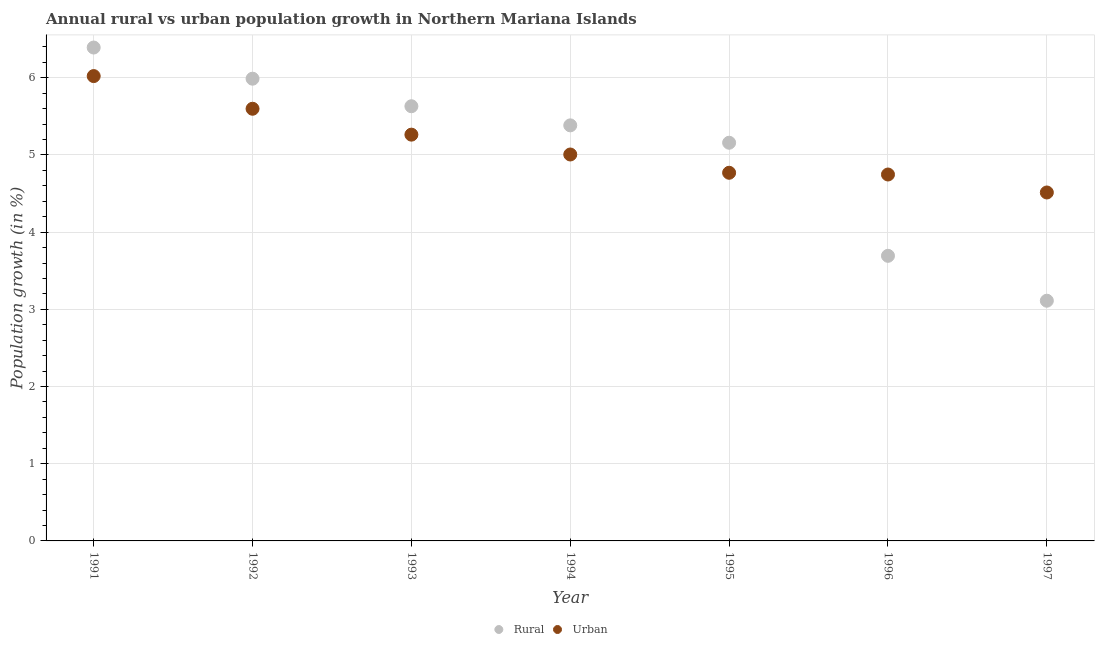How many different coloured dotlines are there?
Make the answer very short. 2. What is the urban population growth in 1996?
Your answer should be compact. 4.75. Across all years, what is the maximum rural population growth?
Keep it short and to the point. 6.39. Across all years, what is the minimum urban population growth?
Give a very brief answer. 4.51. In which year was the rural population growth maximum?
Your answer should be very brief. 1991. What is the total urban population growth in the graph?
Make the answer very short. 35.92. What is the difference between the rural population growth in 1992 and that in 1994?
Provide a succinct answer. 0.6. What is the difference between the urban population growth in 1994 and the rural population growth in 1996?
Provide a succinct answer. 1.31. What is the average rural population growth per year?
Give a very brief answer. 5.05. In the year 1992, what is the difference between the urban population growth and rural population growth?
Offer a very short reply. -0.39. What is the ratio of the rural population growth in 1991 to that in 1995?
Offer a terse response. 1.24. Is the urban population growth in 1991 less than that in 1992?
Ensure brevity in your answer.  No. What is the difference between the highest and the second highest urban population growth?
Offer a terse response. 0.42. What is the difference between the highest and the lowest urban population growth?
Offer a very short reply. 1.51. In how many years, is the rural population growth greater than the average rural population growth taken over all years?
Ensure brevity in your answer.  5. Is the sum of the rural population growth in 1993 and 1995 greater than the maximum urban population growth across all years?
Provide a short and direct response. Yes. Does the urban population growth monotonically increase over the years?
Ensure brevity in your answer.  No. Is the rural population growth strictly greater than the urban population growth over the years?
Give a very brief answer. No. Is the rural population growth strictly less than the urban population growth over the years?
Your answer should be compact. No. How many dotlines are there?
Provide a succinct answer. 2. What is the difference between two consecutive major ticks on the Y-axis?
Offer a terse response. 1. What is the title of the graph?
Provide a short and direct response. Annual rural vs urban population growth in Northern Mariana Islands. What is the label or title of the X-axis?
Provide a succinct answer. Year. What is the label or title of the Y-axis?
Make the answer very short. Population growth (in %). What is the Population growth (in %) of Rural in 1991?
Provide a succinct answer. 6.39. What is the Population growth (in %) of Urban  in 1991?
Your response must be concise. 6.02. What is the Population growth (in %) in Rural in 1992?
Your answer should be very brief. 5.99. What is the Population growth (in %) of Urban  in 1992?
Provide a succinct answer. 5.6. What is the Population growth (in %) of Rural in 1993?
Make the answer very short. 5.63. What is the Population growth (in %) of Urban  in 1993?
Provide a succinct answer. 5.26. What is the Population growth (in %) of Rural in 1994?
Offer a terse response. 5.38. What is the Population growth (in %) of Urban  in 1994?
Provide a succinct answer. 5.01. What is the Population growth (in %) of Rural in 1995?
Your answer should be compact. 5.16. What is the Population growth (in %) of Urban  in 1995?
Your answer should be very brief. 4.77. What is the Population growth (in %) in Rural in 1996?
Make the answer very short. 3.69. What is the Population growth (in %) in Urban  in 1996?
Your answer should be compact. 4.75. What is the Population growth (in %) in Rural in 1997?
Make the answer very short. 3.11. What is the Population growth (in %) of Urban  in 1997?
Keep it short and to the point. 4.51. Across all years, what is the maximum Population growth (in %) of Rural?
Your response must be concise. 6.39. Across all years, what is the maximum Population growth (in %) of Urban ?
Provide a short and direct response. 6.02. Across all years, what is the minimum Population growth (in %) of Rural?
Give a very brief answer. 3.11. Across all years, what is the minimum Population growth (in %) in Urban ?
Provide a succinct answer. 4.51. What is the total Population growth (in %) of Rural in the graph?
Make the answer very short. 35.36. What is the total Population growth (in %) of Urban  in the graph?
Your answer should be compact. 35.92. What is the difference between the Population growth (in %) of Rural in 1991 and that in 1992?
Offer a very short reply. 0.4. What is the difference between the Population growth (in %) in Urban  in 1991 and that in 1992?
Offer a very short reply. 0.42. What is the difference between the Population growth (in %) of Rural in 1991 and that in 1993?
Your response must be concise. 0.76. What is the difference between the Population growth (in %) in Urban  in 1991 and that in 1993?
Offer a very short reply. 0.76. What is the difference between the Population growth (in %) in Rural in 1991 and that in 1994?
Your response must be concise. 1.01. What is the difference between the Population growth (in %) of Urban  in 1991 and that in 1994?
Keep it short and to the point. 1.02. What is the difference between the Population growth (in %) of Rural in 1991 and that in 1995?
Your answer should be very brief. 1.23. What is the difference between the Population growth (in %) in Urban  in 1991 and that in 1995?
Ensure brevity in your answer.  1.25. What is the difference between the Population growth (in %) in Rural in 1991 and that in 1996?
Provide a succinct answer. 2.7. What is the difference between the Population growth (in %) in Urban  in 1991 and that in 1996?
Ensure brevity in your answer.  1.28. What is the difference between the Population growth (in %) in Rural in 1991 and that in 1997?
Make the answer very short. 3.28. What is the difference between the Population growth (in %) in Urban  in 1991 and that in 1997?
Make the answer very short. 1.51. What is the difference between the Population growth (in %) of Rural in 1992 and that in 1993?
Provide a succinct answer. 0.36. What is the difference between the Population growth (in %) of Urban  in 1992 and that in 1993?
Ensure brevity in your answer.  0.34. What is the difference between the Population growth (in %) of Rural in 1992 and that in 1994?
Your answer should be very brief. 0.6. What is the difference between the Population growth (in %) of Urban  in 1992 and that in 1994?
Make the answer very short. 0.59. What is the difference between the Population growth (in %) in Rural in 1992 and that in 1995?
Make the answer very short. 0.83. What is the difference between the Population growth (in %) of Urban  in 1992 and that in 1995?
Give a very brief answer. 0.83. What is the difference between the Population growth (in %) in Rural in 1992 and that in 1996?
Provide a short and direct response. 2.29. What is the difference between the Population growth (in %) of Urban  in 1992 and that in 1996?
Your answer should be compact. 0.85. What is the difference between the Population growth (in %) in Rural in 1992 and that in 1997?
Make the answer very short. 2.88. What is the difference between the Population growth (in %) in Urban  in 1992 and that in 1997?
Keep it short and to the point. 1.08. What is the difference between the Population growth (in %) in Rural in 1993 and that in 1994?
Your answer should be compact. 0.25. What is the difference between the Population growth (in %) in Urban  in 1993 and that in 1994?
Ensure brevity in your answer.  0.26. What is the difference between the Population growth (in %) in Rural in 1993 and that in 1995?
Give a very brief answer. 0.47. What is the difference between the Population growth (in %) in Urban  in 1993 and that in 1995?
Your response must be concise. 0.49. What is the difference between the Population growth (in %) of Rural in 1993 and that in 1996?
Ensure brevity in your answer.  1.94. What is the difference between the Population growth (in %) of Urban  in 1993 and that in 1996?
Your response must be concise. 0.52. What is the difference between the Population growth (in %) in Rural in 1993 and that in 1997?
Provide a succinct answer. 2.52. What is the difference between the Population growth (in %) in Urban  in 1993 and that in 1997?
Offer a terse response. 0.75. What is the difference between the Population growth (in %) of Rural in 1994 and that in 1995?
Your answer should be compact. 0.23. What is the difference between the Population growth (in %) in Urban  in 1994 and that in 1995?
Give a very brief answer. 0.24. What is the difference between the Population growth (in %) of Rural in 1994 and that in 1996?
Provide a succinct answer. 1.69. What is the difference between the Population growth (in %) in Urban  in 1994 and that in 1996?
Your answer should be compact. 0.26. What is the difference between the Population growth (in %) in Rural in 1994 and that in 1997?
Your answer should be compact. 2.27. What is the difference between the Population growth (in %) in Urban  in 1994 and that in 1997?
Your answer should be very brief. 0.49. What is the difference between the Population growth (in %) of Rural in 1995 and that in 1996?
Your response must be concise. 1.47. What is the difference between the Population growth (in %) of Urban  in 1995 and that in 1996?
Make the answer very short. 0.02. What is the difference between the Population growth (in %) in Rural in 1995 and that in 1997?
Your answer should be very brief. 2.05. What is the difference between the Population growth (in %) in Urban  in 1995 and that in 1997?
Give a very brief answer. 0.26. What is the difference between the Population growth (in %) in Rural in 1996 and that in 1997?
Offer a terse response. 0.58. What is the difference between the Population growth (in %) of Urban  in 1996 and that in 1997?
Your answer should be very brief. 0.23. What is the difference between the Population growth (in %) of Rural in 1991 and the Population growth (in %) of Urban  in 1992?
Your answer should be compact. 0.79. What is the difference between the Population growth (in %) in Rural in 1991 and the Population growth (in %) in Urban  in 1993?
Offer a terse response. 1.13. What is the difference between the Population growth (in %) of Rural in 1991 and the Population growth (in %) of Urban  in 1994?
Ensure brevity in your answer.  1.39. What is the difference between the Population growth (in %) in Rural in 1991 and the Population growth (in %) in Urban  in 1995?
Offer a terse response. 1.62. What is the difference between the Population growth (in %) of Rural in 1991 and the Population growth (in %) of Urban  in 1996?
Provide a succinct answer. 1.64. What is the difference between the Population growth (in %) of Rural in 1991 and the Population growth (in %) of Urban  in 1997?
Provide a short and direct response. 1.88. What is the difference between the Population growth (in %) in Rural in 1992 and the Population growth (in %) in Urban  in 1993?
Ensure brevity in your answer.  0.72. What is the difference between the Population growth (in %) of Rural in 1992 and the Population growth (in %) of Urban  in 1994?
Your answer should be very brief. 0.98. What is the difference between the Population growth (in %) of Rural in 1992 and the Population growth (in %) of Urban  in 1995?
Ensure brevity in your answer.  1.22. What is the difference between the Population growth (in %) in Rural in 1992 and the Population growth (in %) in Urban  in 1996?
Make the answer very short. 1.24. What is the difference between the Population growth (in %) in Rural in 1992 and the Population growth (in %) in Urban  in 1997?
Keep it short and to the point. 1.47. What is the difference between the Population growth (in %) in Rural in 1993 and the Population growth (in %) in Urban  in 1994?
Keep it short and to the point. 0.63. What is the difference between the Population growth (in %) in Rural in 1993 and the Population growth (in %) in Urban  in 1995?
Provide a succinct answer. 0.86. What is the difference between the Population growth (in %) of Rural in 1993 and the Population growth (in %) of Urban  in 1996?
Ensure brevity in your answer.  0.88. What is the difference between the Population growth (in %) in Rural in 1993 and the Population growth (in %) in Urban  in 1997?
Ensure brevity in your answer.  1.12. What is the difference between the Population growth (in %) in Rural in 1994 and the Population growth (in %) in Urban  in 1995?
Your answer should be compact. 0.61. What is the difference between the Population growth (in %) of Rural in 1994 and the Population growth (in %) of Urban  in 1996?
Ensure brevity in your answer.  0.64. What is the difference between the Population growth (in %) in Rural in 1994 and the Population growth (in %) in Urban  in 1997?
Give a very brief answer. 0.87. What is the difference between the Population growth (in %) in Rural in 1995 and the Population growth (in %) in Urban  in 1996?
Provide a short and direct response. 0.41. What is the difference between the Population growth (in %) of Rural in 1995 and the Population growth (in %) of Urban  in 1997?
Offer a terse response. 0.64. What is the difference between the Population growth (in %) in Rural in 1996 and the Population growth (in %) in Urban  in 1997?
Give a very brief answer. -0.82. What is the average Population growth (in %) of Rural per year?
Provide a succinct answer. 5.05. What is the average Population growth (in %) of Urban  per year?
Your response must be concise. 5.13. In the year 1991, what is the difference between the Population growth (in %) in Rural and Population growth (in %) in Urban ?
Provide a succinct answer. 0.37. In the year 1992, what is the difference between the Population growth (in %) in Rural and Population growth (in %) in Urban ?
Offer a very short reply. 0.39. In the year 1993, what is the difference between the Population growth (in %) in Rural and Population growth (in %) in Urban ?
Keep it short and to the point. 0.37. In the year 1994, what is the difference between the Population growth (in %) in Rural and Population growth (in %) in Urban ?
Offer a terse response. 0.38. In the year 1995, what is the difference between the Population growth (in %) in Rural and Population growth (in %) in Urban ?
Provide a short and direct response. 0.39. In the year 1996, what is the difference between the Population growth (in %) of Rural and Population growth (in %) of Urban ?
Keep it short and to the point. -1.05. In the year 1997, what is the difference between the Population growth (in %) in Rural and Population growth (in %) in Urban ?
Offer a very short reply. -1.4. What is the ratio of the Population growth (in %) of Rural in 1991 to that in 1992?
Your answer should be very brief. 1.07. What is the ratio of the Population growth (in %) of Urban  in 1991 to that in 1992?
Offer a very short reply. 1.08. What is the ratio of the Population growth (in %) in Rural in 1991 to that in 1993?
Your response must be concise. 1.14. What is the ratio of the Population growth (in %) of Urban  in 1991 to that in 1993?
Offer a very short reply. 1.14. What is the ratio of the Population growth (in %) of Rural in 1991 to that in 1994?
Your response must be concise. 1.19. What is the ratio of the Population growth (in %) of Urban  in 1991 to that in 1994?
Offer a very short reply. 1.2. What is the ratio of the Population growth (in %) of Rural in 1991 to that in 1995?
Your response must be concise. 1.24. What is the ratio of the Population growth (in %) of Urban  in 1991 to that in 1995?
Your answer should be compact. 1.26. What is the ratio of the Population growth (in %) in Rural in 1991 to that in 1996?
Keep it short and to the point. 1.73. What is the ratio of the Population growth (in %) in Urban  in 1991 to that in 1996?
Your answer should be compact. 1.27. What is the ratio of the Population growth (in %) in Rural in 1991 to that in 1997?
Offer a very short reply. 2.05. What is the ratio of the Population growth (in %) in Urban  in 1991 to that in 1997?
Keep it short and to the point. 1.33. What is the ratio of the Population growth (in %) of Rural in 1992 to that in 1993?
Ensure brevity in your answer.  1.06. What is the ratio of the Population growth (in %) in Urban  in 1992 to that in 1993?
Your response must be concise. 1.06. What is the ratio of the Population growth (in %) of Rural in 1992 to that in 1994?
Provide a short and direct response. 1.11. What is the ratio of the Population growth (in %) of Urban  in 1992 to that in 1994?
Provide a succinct answer. 1.12. What is the ratio of the Population growth (in %) of Rural in 1992 to that in 1995?
Your response must be concise. 1.16. What is the ratio of the Population growth (in %) of Urban  in 1992 to that in 1995?
Your answer should be compact. 1.17. What is the ratio of the Population growth (in %) of Rural in 1992 to that in 1996?
Provide a short and direct response. 1.62. What is the ratio of the Population growth (in %) of Urban  in 1992 to that in 1996?
Make the answer very short. 1.18. What is the ratio of the Population growth (in %) in Rural in 1992 to that in 1997?
Provide a short and direct response. 1.92. What is the ratio of the Population growth (in %) of Urban  in 1992 to that in 1997?
Provide a succinct answer. 1.24. What is the ratio of the Population growth (in %) in Rural in 1993 to that in 1994?
Offer a very short reply. 1.05. What is the ratio of the Population growth (in %) of Urban  in 1993 to that in 1994?
Make the answer very short. 1.05. What is the ratio of the Population growth (in %) in Rural in 1993 to that in 1995?
Give a very brief answer. 1.09. What is the ratio of the Population growth (in %) in Urban  in 1993 to that in 1995?
Your answer should be compact. 1.1. What is the ratio of the Population growth (in %) of Rural in 1993 to that in 1996?
Your response must be concise. 1.52. What is the ratio of the Population growth (in %) of Urban  in 1993 to that in 1996?
Make the answer very short. 1.11. What is the ratio of the Population growth (in %) of Rural in 1993 to that in 1997?
Offer a terse response. 1.81. What is the ratio of the Population growth (in %) of Urban  in 1993 to that in 1997?
Keep it short and to the point. 1.17. What is the ratio of the Population growth (in %) of Rural in 1994 to that in 1995?
Offer a terse response. 1.04. What is the ratio of the Population growth (in %) in Urban  in 1994 to that in 1995?
Offer a terse response. 1.05. What is the ratio of the Population growth (in %) in Rural in 1994 to that in 1996?
Provide a succinct answer. 1.46. What is the ratio of the Population growth (in %) of Urban  in 1994 to that in 1996?
Make the answer very short. 1.05. What is the ratio of the Population growth (in %) of Rural in 1994 to that in 1997?
Offer a terse response. 1.73. What is the ratio of the Population growth (in %) of Urban  in 1994 to that in 1997?
Your response must be concise. 1.11. What is the ratio of the Population growth (in %) in Rural in 1995 to that in 1996?
Offer a very short reply. 1.4. What is the ratio of the Population growth (in %) in Rural in 1995 to that in 1997?
Provide a succinct answer. 1.66. What is the ratio of the Population growth (in %) of Urban  in 1995 to that in 1997?
Your answer should be very brief. 1.06. What is the ratio of the Population growth (in %) of Rural in 1996 to that in 1997?
Your response must be concise. 1.19. What is the ratio of the Population growth (in %) of Urban  in 1996 to that in 1997?
Ensure brevity in your answer.  1.05. What is the difference between the highest and the second highest Population growth (in %) in Rural?
Provide a succinct answer. 0.4. What is the difference between the highest and the second highest Population growth (in %) of Urban ?
Provide a short and direct response. 0.42. What is the difference between the highest and the lowest Population growth (in %) in Rural?
Your answer should be compact. 3.28. What is the difference between the highest and the lowest Population growth (in %) in Urban ?
Offer a very short reply. 1.51. 